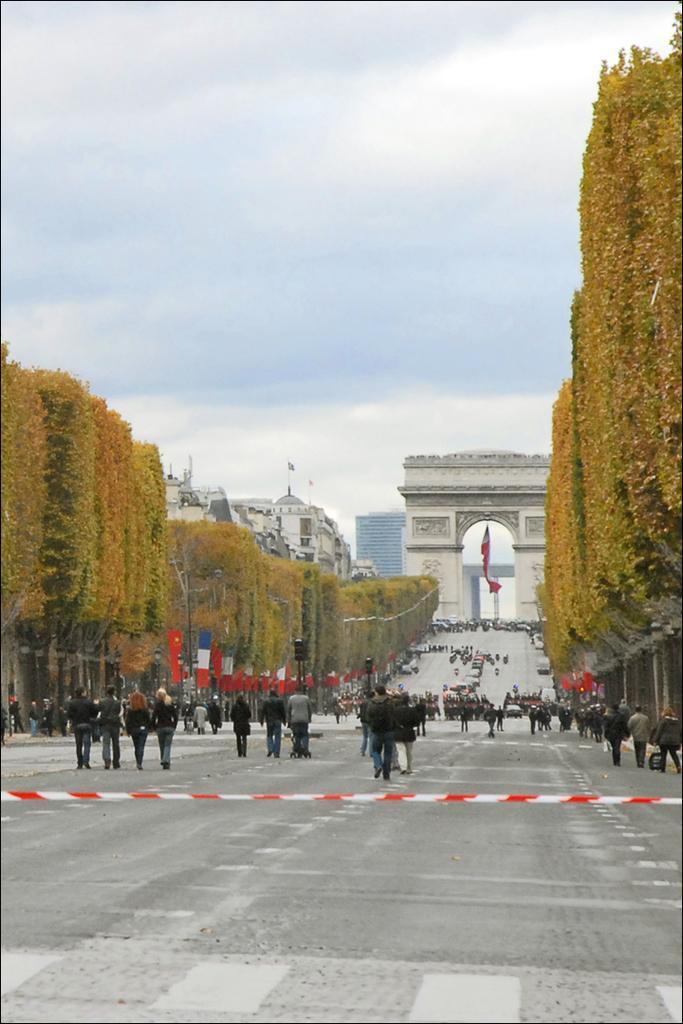In one or two sentences, can you explain what this image depicts? In this image we can see many trees. We can also see the monument, flag, traffic signal poles and some information boards and also the buildings. We can also see many people walking on the road. There is sky with some clouds. 